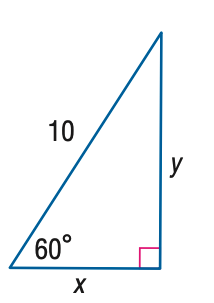Answer the mathemtical geometry problem and directly provide the correct option letter.
Question: Find y.
Choices: A: 5 B: 5 \sqrt { 2 } C: 5 \sqrt { 3 } D: 10 C 